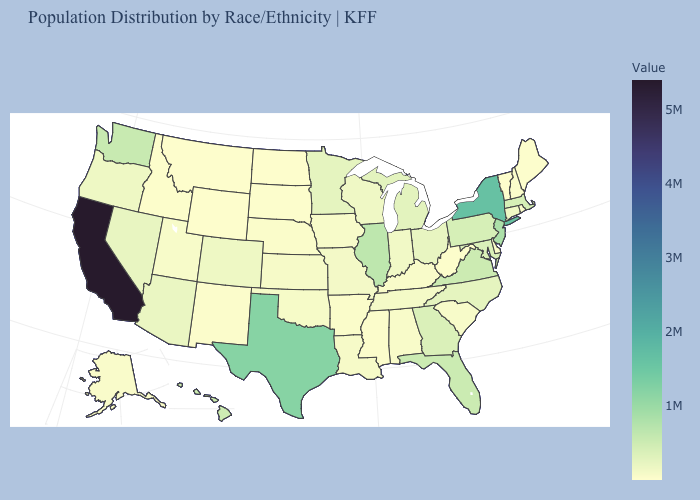Does West Virginia have the lowest value in the South?
Give a very brief answer. Yes. Among the states that border Vermont , which have the lowest value?
Write a very short answer. New Hampshire. Which states have the lowest value in the USA?
Concise answer only. Wyoming. Among the states that border Maryland , does Virginia have the lowest value?
Concise answer only. No. Among the states that border Alabama , which have the highest value?
Answer briefly. Florida. 